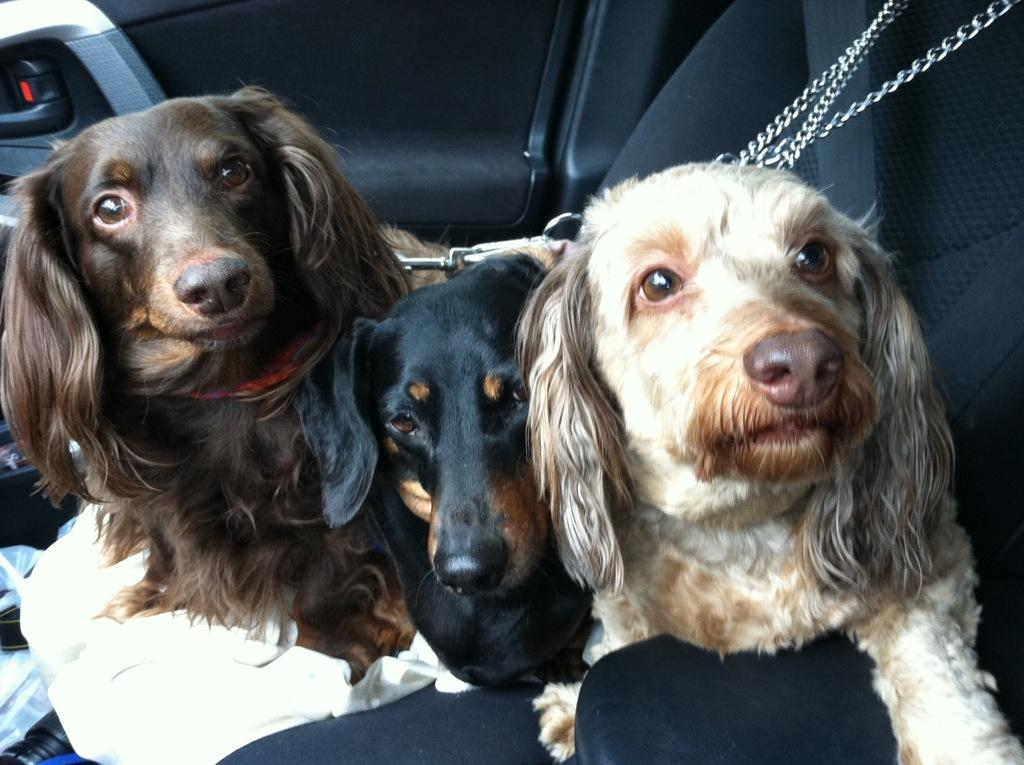What animals are present in the vehicle? There are dogs in the vehicle. How are the dogs secured in the vehicle? The dogs are attached with a chain. What type of pickle is being used as a leash for the dogs in the image? There is no pickle present in the image, and the dogs are attached with a chain, not a pickle. 